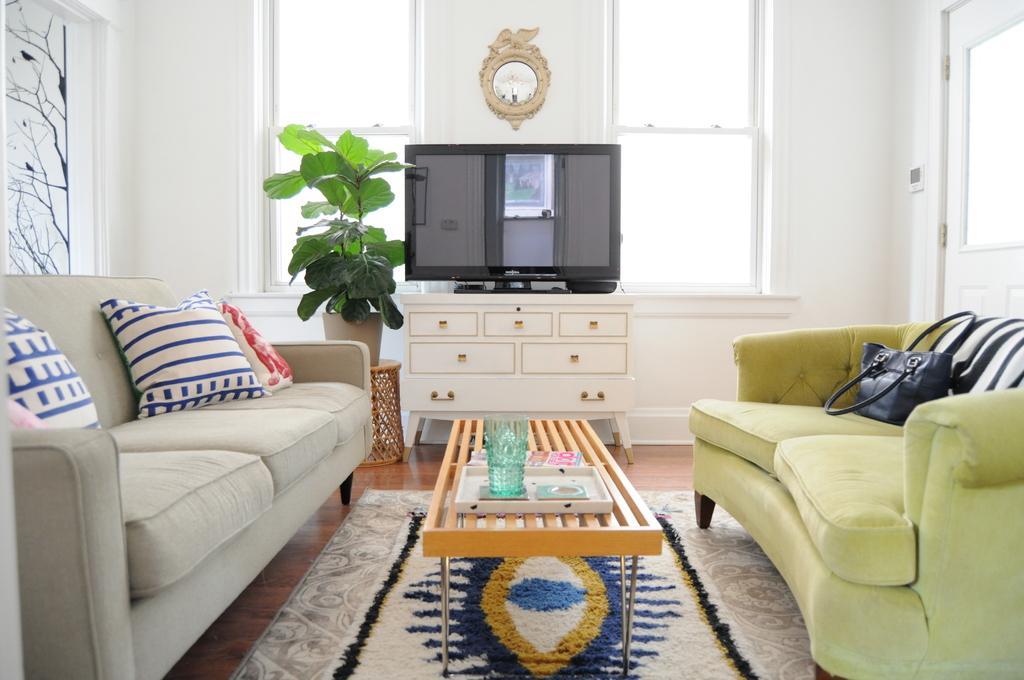Can you describe this image briefly? In this picture we can see the inside view of a room. This is the TV and there is a cupboard. These are two sofas in the room and there is a bag on the sofa. These are the pillows and we can see the wall and these are the windows. And there is a plant and even we can see the table here. And there is a tray on the table. And this is the clock. 